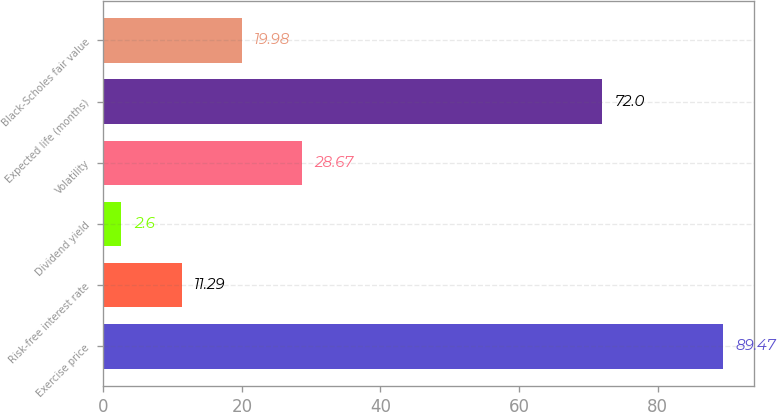<chart> <loc_0><loc_0><loc_500><loc_500><bar_chart><fcel>Exercise price<fcel>Risk-free interest rate<fcel>Dividend yield<fcel>Volatility<fcel>Expected life (months)<fcel>Black-Scholes fair value<nl><fcel>89.47<fcel>11.29<fcel>2.6<fcel>28.67<fcel>72<fcel>19.98<nl></chart> 